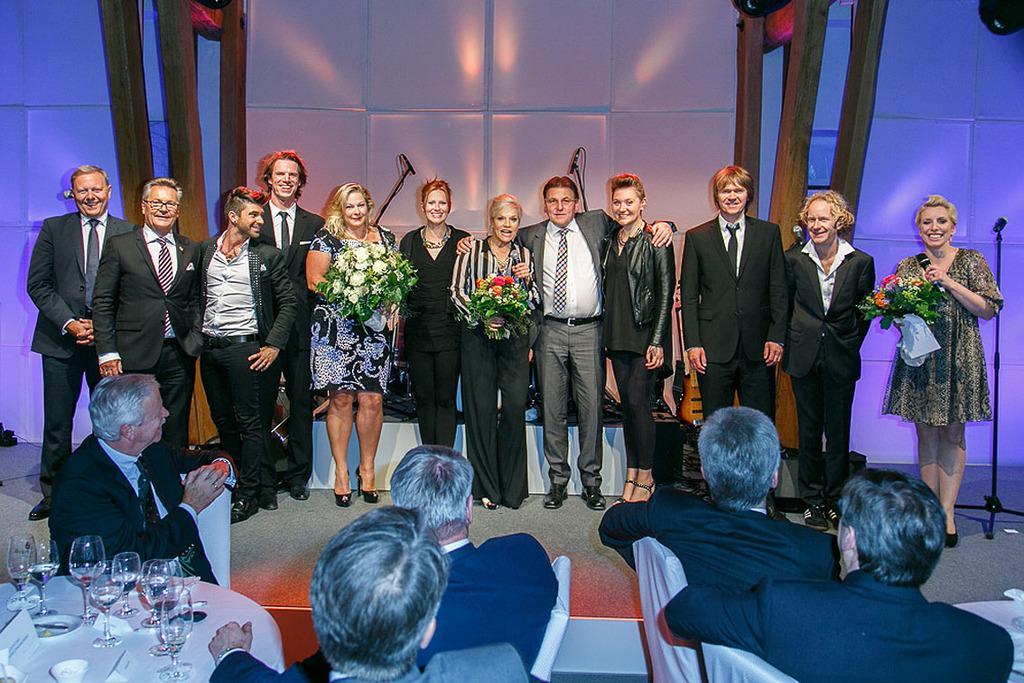Could you give a brief overview of what you see in this image? In the foreground of this picture, there are men sitting on the chair near a table and we can see glasses on the table. In the background, there are persons standing and posing to a camera and behind them there is a wall and mics. 